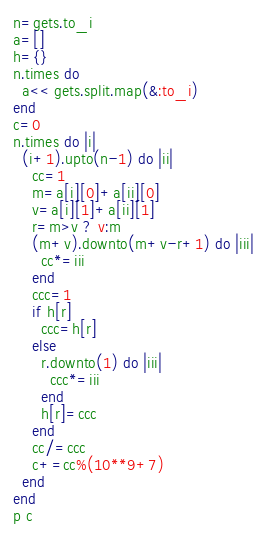<code> <loc_0><loc_0><loc_500><loc_500><_Ruby_>n=gets.to_i
a=[]
h={}
n.times do
  a<< gets.split.map(&:to_i)
end
c=0
n.times do |i|
  (i+1).upto(n-1) do |ii|
    cc=1
    m=a[i][0]+a[ii][0]
    v=a[i][1]+a[ii][1]
    r=m>v ? v:m
    (m+v).downto(m+v-r+1) do |iii|
      cc*=iii
    end
    ccc=1
    if h[r]
      ccc=h[r]
    else
      r.downto(1) do |iii|
        ccc*=iii
      end
      h[r]=ccc
    end
    cc/=ccc
    c+=cc%(10**9+7)
  end
end
p c</code> 